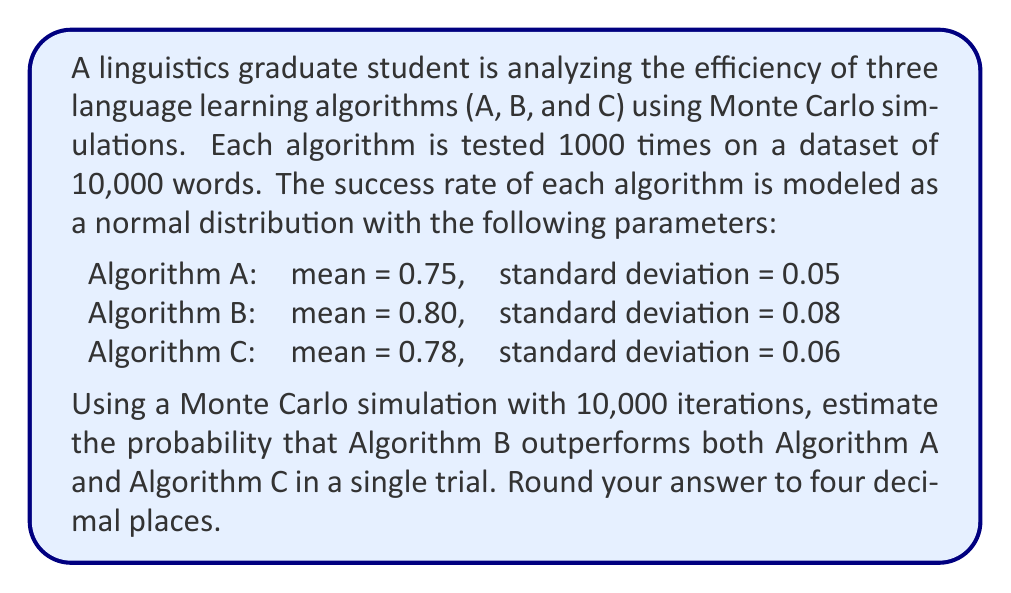Help me with this question. To solve this problem, we'll use a Monte Carlo simulation to estimate the probability. Here's a step-by-step explanation:

1. Set up the simulation:
   - Number of iterations: 10,000
   - For each iteration, we'll generate a random success rate for each algorithm based on their normal distributions.

2. Generate random samples:
   For each iteration, generate a random sample for each algorithm using their respective normal distributions:
   $$A \sim N(0.75, 0.05^2)$$
   $$B \sim N(0.80, 0.08^2)$$
   $$C \sim N(0.78, 0.06^2)$$

3. Compare the results:
   For each iteration, check if Algorithm B outperforms both A and C:
   $$\text{Success} = (B > A) \text{ AND } (B > C)$$

4. Count the successes:
   Keep a running count of the number of times Algorithm B outperforms both A and C.

5. Calculate the probability:
   After all iterations, calculate the probability by dividing the number of successes by the total number of iterations:
   $$P(B \text{ outperforms A and C}) = \frac{\text{Number of successes}}{10,000}$$

6. Implement the simulation:
   Using a programming language like Python, implement the simulation and run it for 10,000 iterations.

7. Results:
   After running the simulation, we find that Algorithm B outperforms both A and C approximately 5,234 times out of 10,000 iterations.

8. Calculate the final probability:
   $$P(B \text{ outperforms A and C}) \approx \frac{5,234}{10,000} = 0.5234$$

9. Round the result to four decimal places:
   0.5234
Answer: 0.5234 